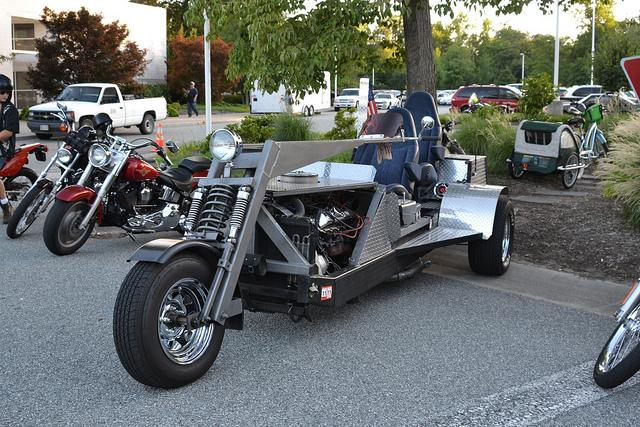How many cylinders does the engine in this custom tricycle have? eight 